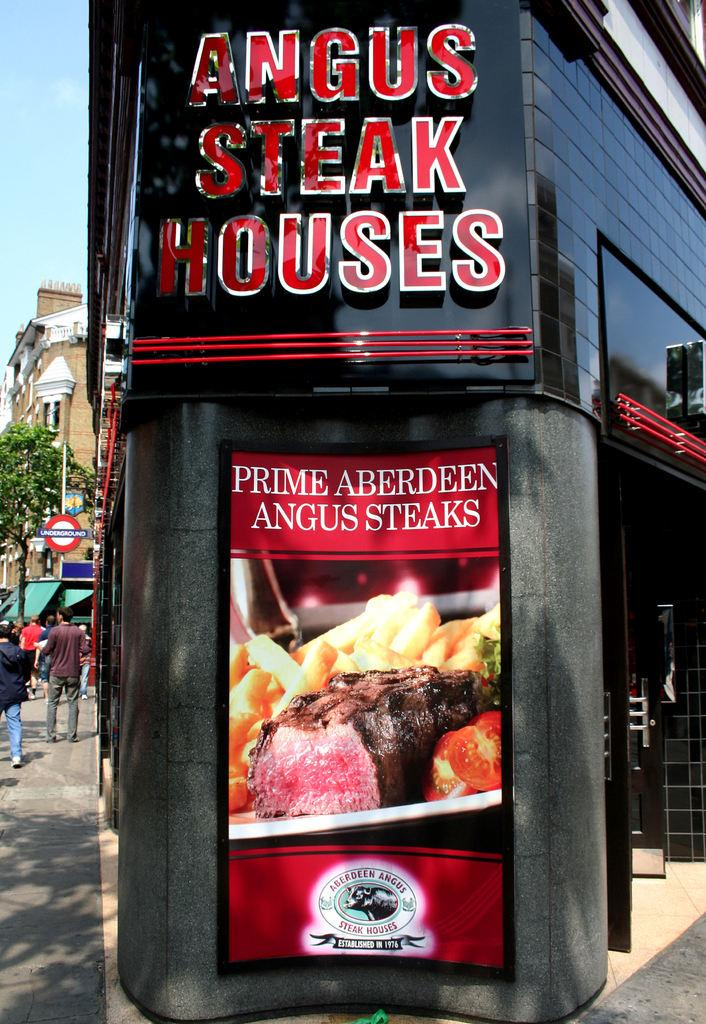<image>
Relay a brief, clear account of the picture shown. Large advertisement for a steak restaurant, Prime Aberdeen Angus steaks 